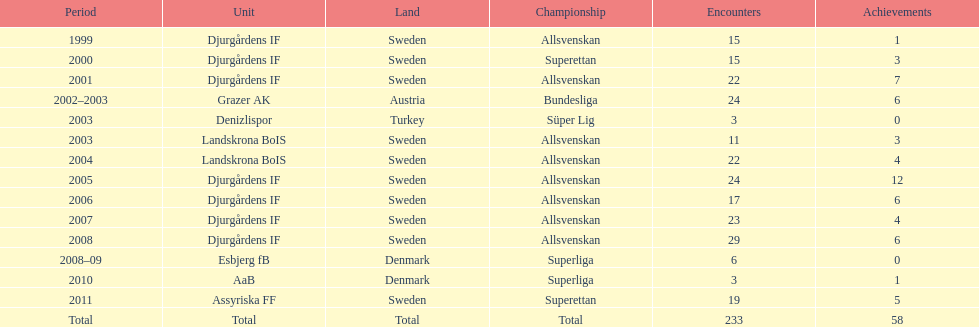What was the number of goals he scored in 2005? 12. 